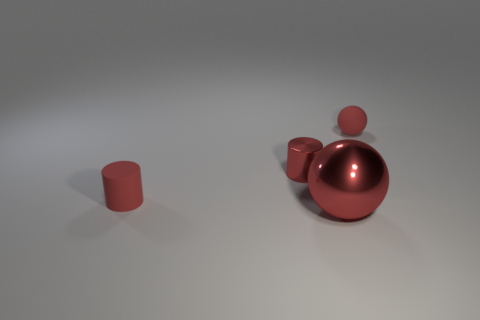There is a rubber object that is the same color as the rubber sphere; what shape is it?
Give a very brief answer. Cylinder. How many other objects are there of the same size as the red shiny sphere?
Your answer should be compact. 0. Is there any other thing that is the same shape as the tiny red metallic thing?
Provide a short and direct response. Yes. Are there an equal number of large red metal objects in front of the large object and red metallic cylinders?
Provide a succinct answer. No. How many large spheres are the same material as the big thing?
Keep it short and to the point. 0. The cylinder that is made of the same material as the large sphere is what color?
Provide a succinct answer. Red. Is the shape of the large red shiny thing the same as the tiny shiny thing?
Provide a succinct answer. No. There is a red sphere that is in front of the small rubber object that is to the left of the large red shiny thing; is there a large red sphere that is in front of it?
Provide a short and direct response. No. How many tiny metal cylinders are the same color as the small ball?
Offer a very short reply. 1. What is the shape of the red rubber thing that is the same size as the red matte ball?
Provide a short and direct response. Cylinder. 